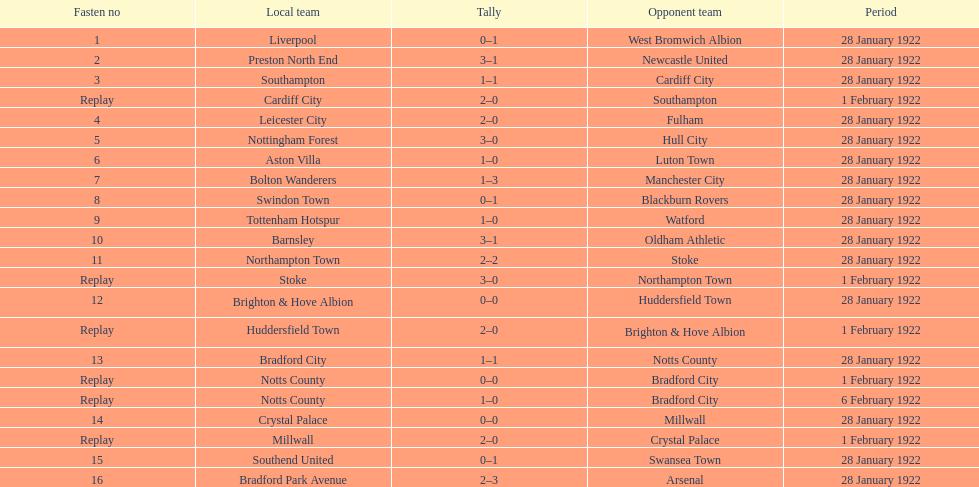How many games had no points registered? 3. 